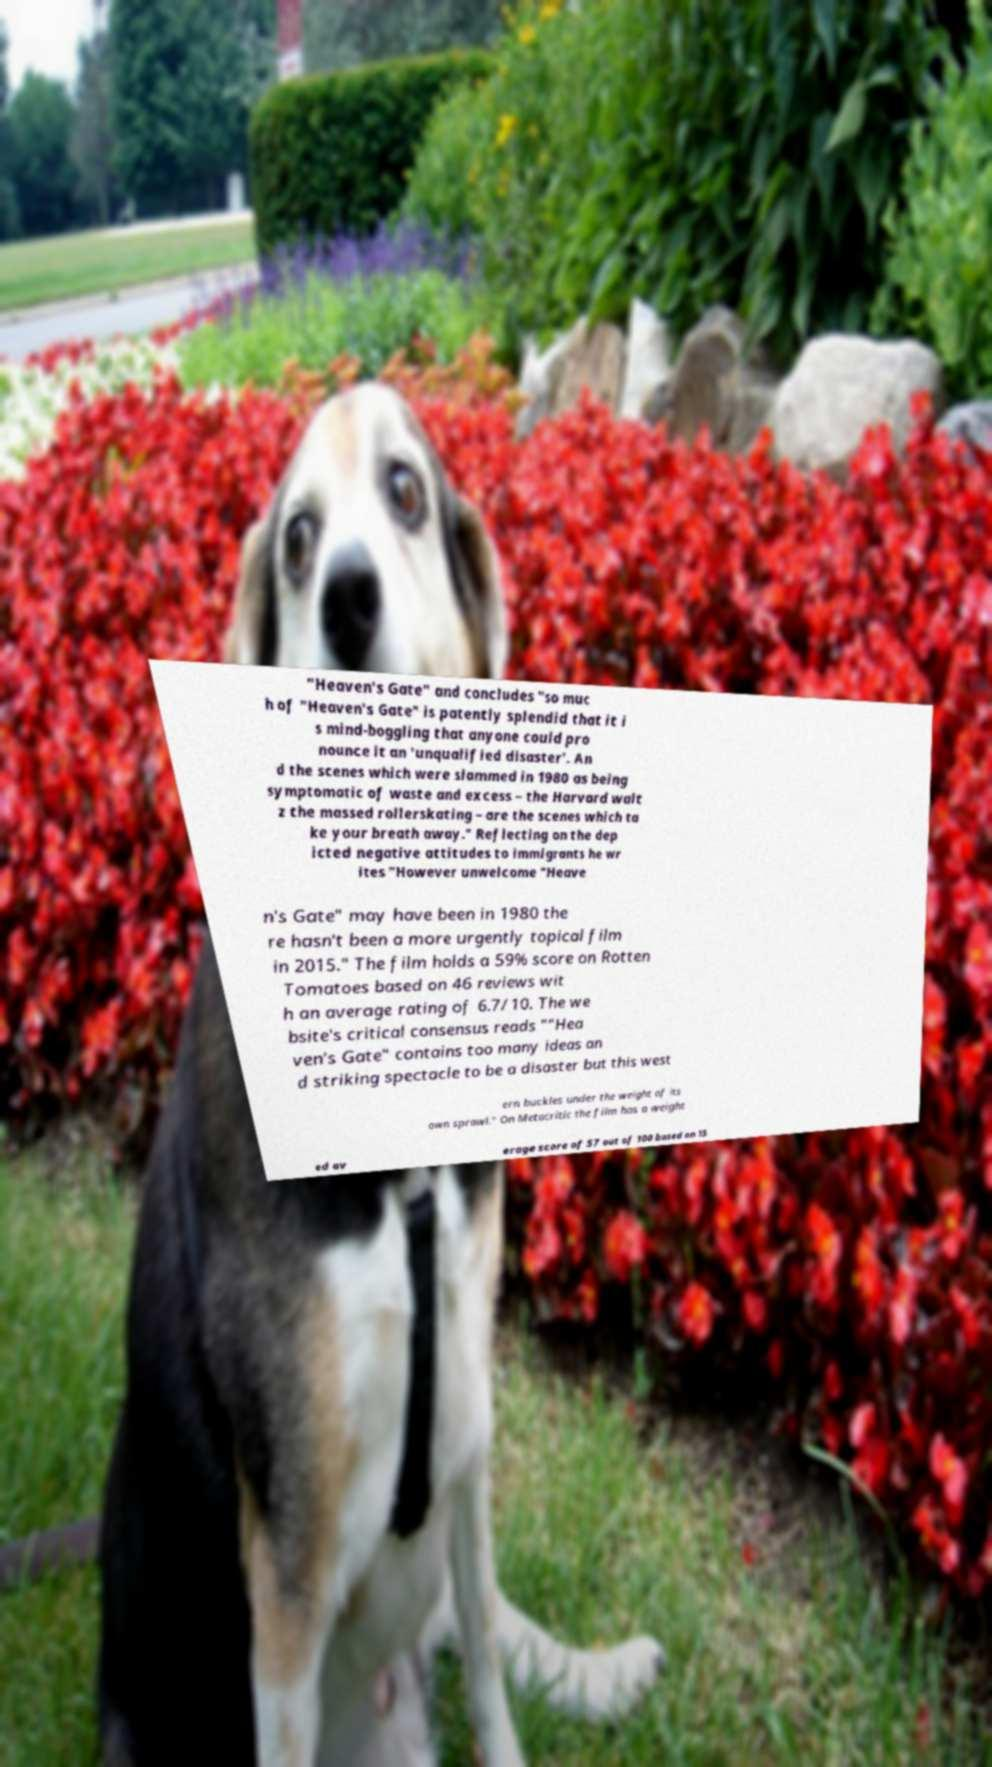I need the written content from this picture converted into text. Can you do that? "Heaven's Gate" and concludes "so muc h of "Heaven's Gate" is patently splendid that it i s mind-boggling that anyone could pro nounce it an 'unqualified disaster'. An d the scenes which were slammed in 1980 as being symptomatic of waste and excess – the Harvard walt z the massed rollerskating – are the scenes which ta ke your breath away." Reflecting on the dep icted negative attitudes to immigrants he wr ites "However unwelcome "Heave n's Gate" may have been in 1980 the re hasn't been a more urgently topical film in 2015." The film holds a 59% score on Rotten Tomatoes based on 46 reviews wit h an average rating of 6.7/10. The we bsite's critical consensus reads ""Hea ven's Gate" contains too many ideas an d striking spectacle to be a disaster but this west ern buckles under the weight of its own sprawl." On Metacritic the film has a weight ed av erage score of 57 out of 100 based on 15 